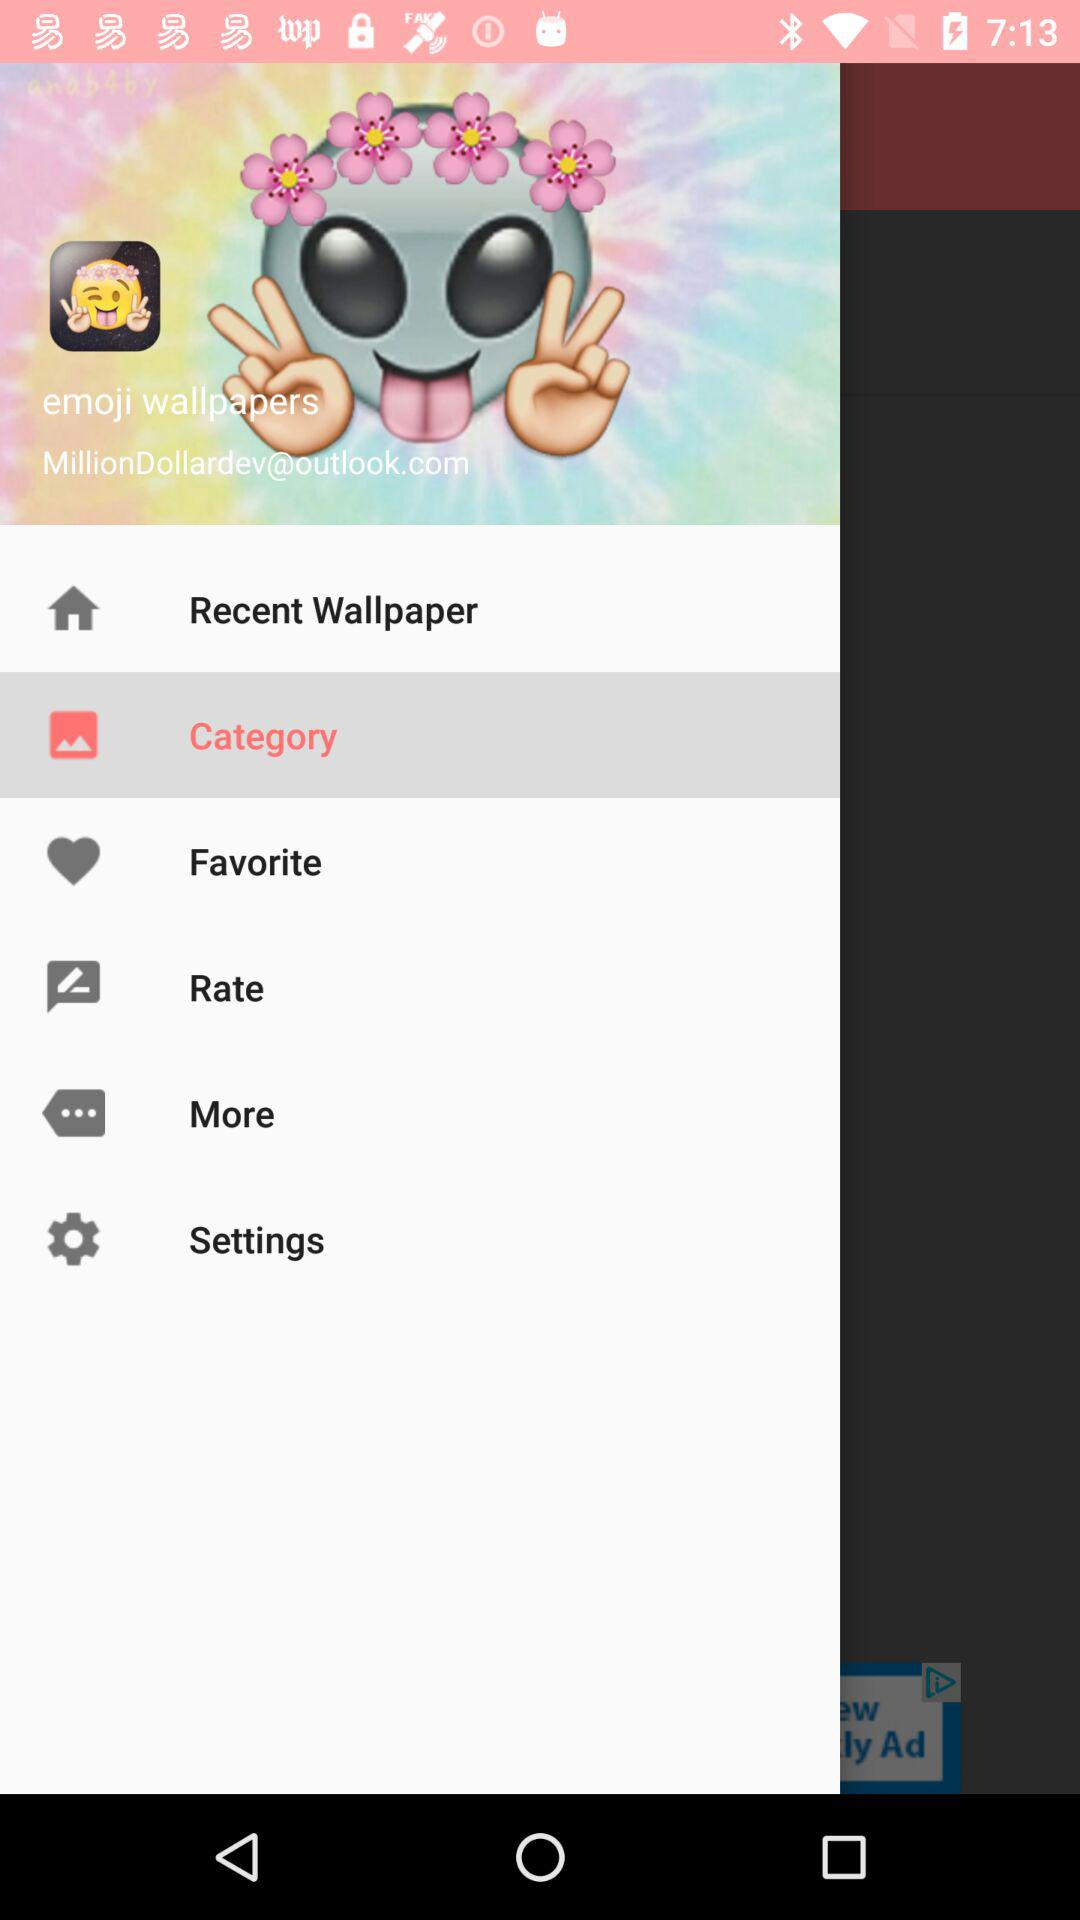What is the email address? The email address is MillionDollardev@outlook.com. 